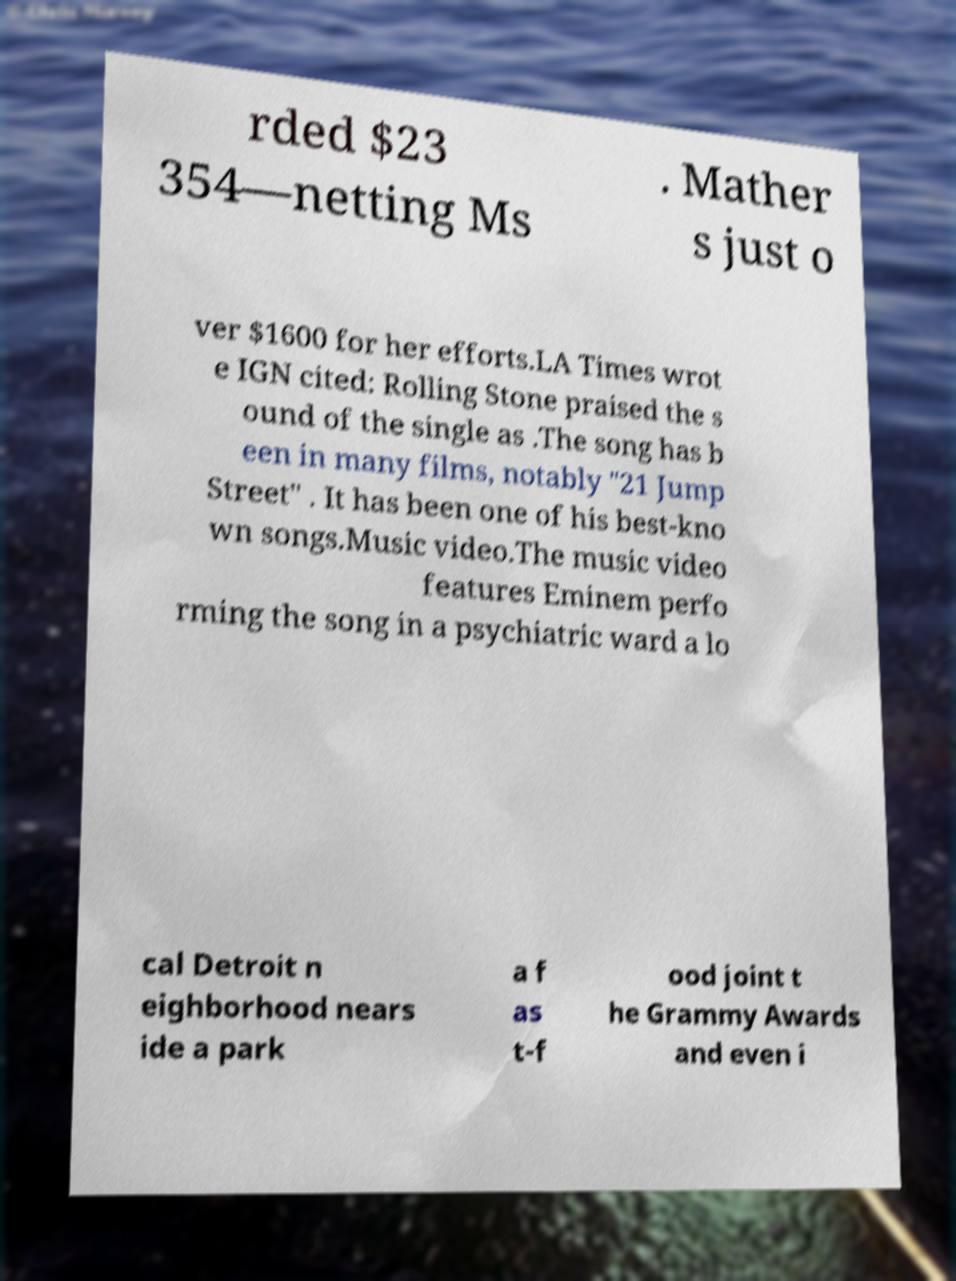What messages or text are displayed in this image? I need them in a readable, typed format. rded $23 354—netting Ms . Mather s just o ver $1600 for her efforts.LA Times wrot e IGN cited: Rolling Stone praised the s ound of the single as .The song has b een in many films, notably "21 Jump Street" . It has been one of his best-kno wn songs.Music video.The music video features Eminem perfo rming the song in a psychiatric ward a lo cal Detroit n eighborhood nears ide a park a f as t-f ood joint t he Grammy Awards and even i 